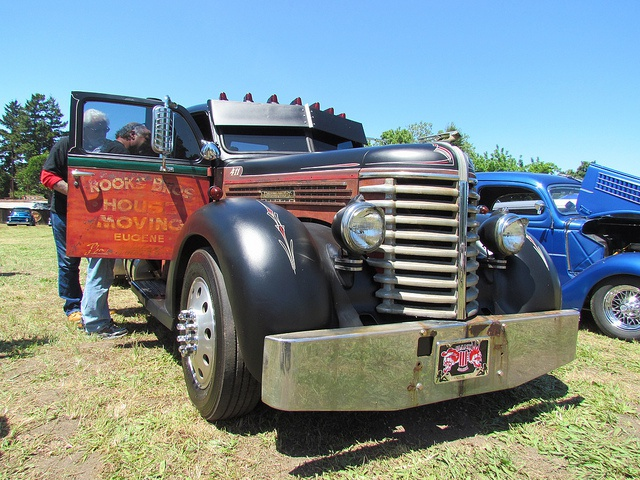Describe the objects in this image and their specific colors. I can see truck in lightblue, black, gray, olive, and darkgray tones, car in lightblue, black, blue, and darkblue tones, truck in lightblue, black, blue, and darkblue tones, people in lightblue, black, gray, blue, and navy tones, and people in lightblue, black, gray, and blue tones in this image. 